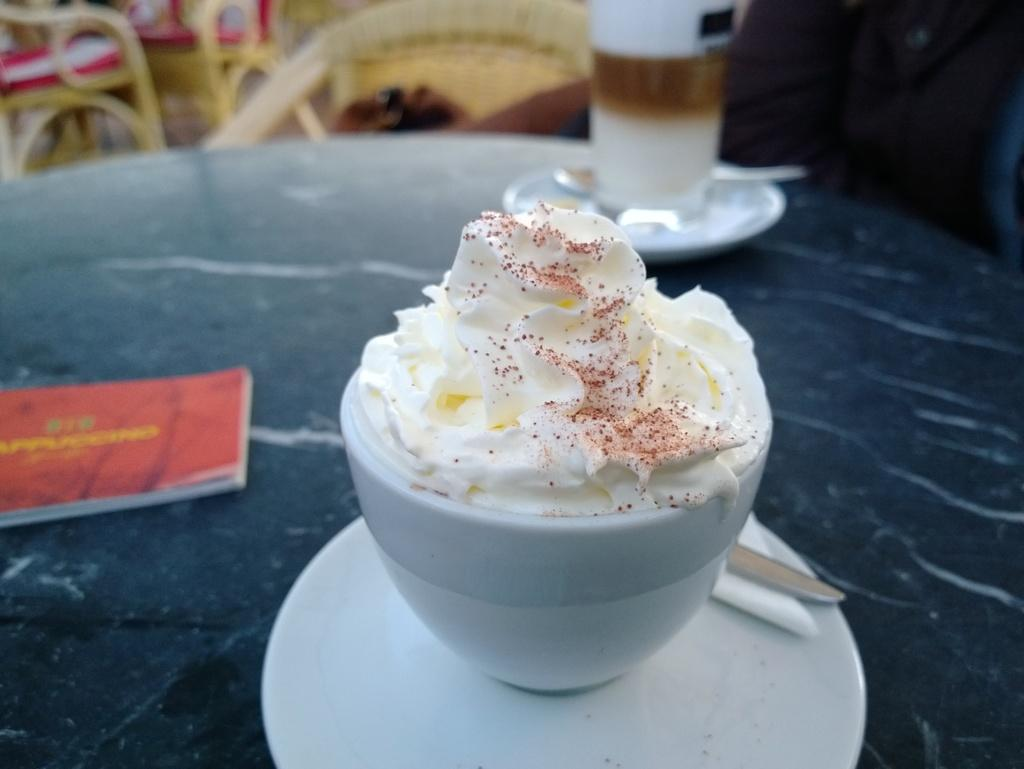What type of food is featured in the image? There is a dessert in the image. How is the dessert being served? The dessert is served with a saucer. What else can be seen beside the dessert? There are two other items beside the dessert. Where are the dessert and the other items located? The dessert and the other items are on a table. Can you describe the background of the image? The background of the image is blurred. What type of potato is being prepared in the image? There is no potato present in the image. 